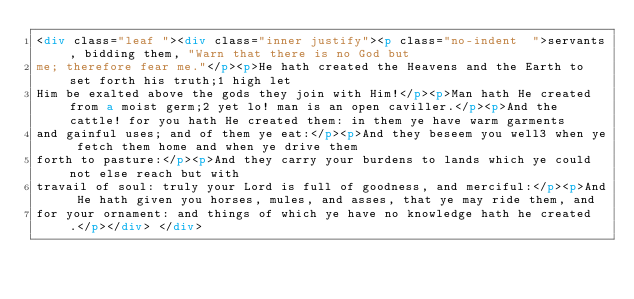Convert code to text. <code><loc_0><loc_0><loc_500><loc_500><_HTML_><div class="leaf "><div class="inner justify"><p class="no-indent  ">servants, bidding them, "Warn that there is no God but
me; therefore fear me."</p><p>He hath created the Heavens and the Earth to set forth his truth;1 high let
Him be exalted above the gods they join with Him!</p><p>Man hath He created from a moist germ;2 yet lo! man is an open caviller.</p><p>And the cattle! for you hath He created them: in them ye have warm garments
and gainful uses; and of them ye eat:</p><p>And they beseem you well3 when ye fetch them home and when ye drive them
forth to pasture:</p><p>And they carry your burdens to lands which ye could not else reach but with
travail of soul: truly your Lord is full of goodness, and merciful:</p><p>And He hath given you horses, mules, and asses, that ye may ride them, and
for your ornament: and things of which ye have no knowledge hath he created.</p></div> </div></code> 